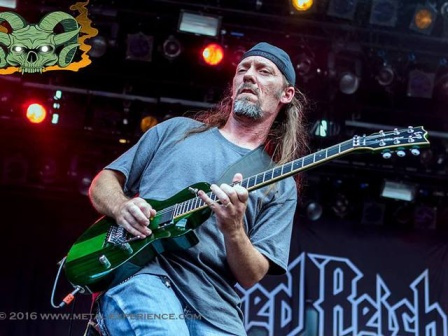What's happening in the scene? In the foreground, a man, energetically immersed in his performance, is playing a vibrant green electric guitar. He stands on a stage, dressed casually in a gray t-shirt, and sports a black bandana, giving him a distinctive rockstar appearance. His focused expression and firm grip on the guitar suggest he's in the middle of an intense musical set.

The stage is adorned with a black banner behind him, boldly displaying the words 'Red Beach'. This could either represent the name of the band he's performing with or the event's title. Adding a unique visual touch, there is a green skull graphic on the left side of the stage. The dark backdrop makes the text and graphics pop out, enhancing the overall edgy and vibrant atmosphere of the performance.

Overall, the image captures a dynamic and high-energy moment, emphasizing the musician's passion and the thematic elements of the performance setting. 